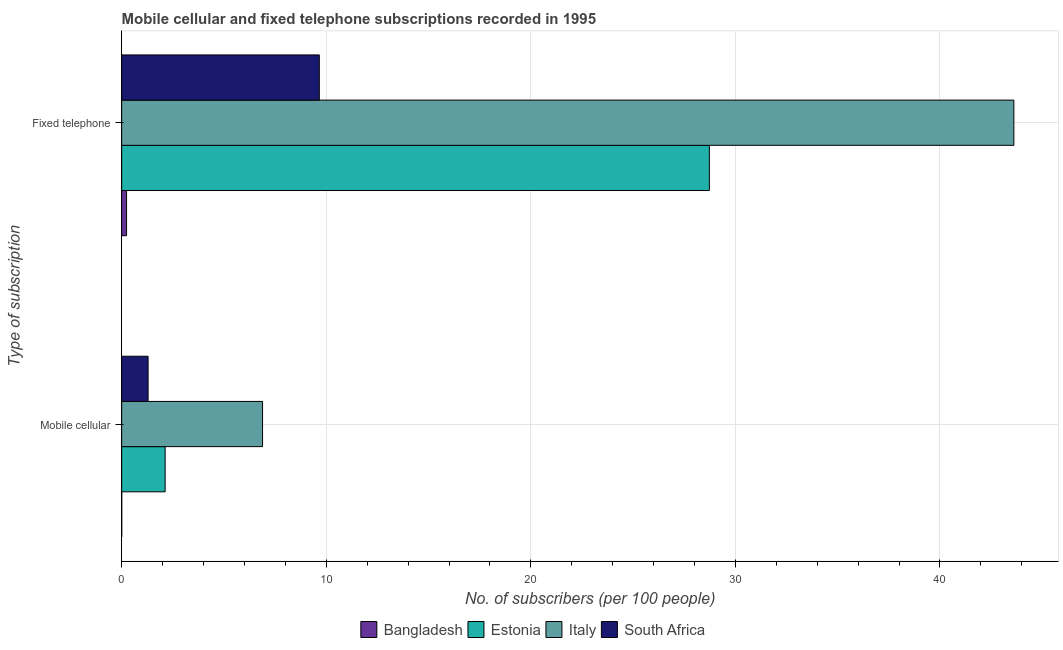How many different coloured bars are there?
Make the answer very short. 4. How many groups of bars are there?
Provide a succinct answer. 2. Are the number of bars on each tick of the Y-axis equal?
Your answer should be very brief. Yes. What is the label of the 1st group of bars from the top?
Offer a terse response. Fixed telephone. What is the number of fixed telephone subscribers in Italy?
Provide a short and direct response. 43.61. Across all countries, what is the maximum number of mobile cellular subscribers?
Your answer should be very brief. 6.89. Across all countries, what is the minimum number of fixed telephone subscribers?
Your answer should be compact. 0.24. In which country was the number of mobile cellular subscribers minimum?
Make the answer very short. Bangladesh. What is the total number of fixed telephone subscribers in the graph?
Ensure brevity in your answer.  82.24. What is the difference between the number of mobile cellular subscribers in Bangladesh and that in Italy?
Your answer should be compact. -6.88. What is the difference between the number of fixed telephone subscribers in Italy and the number of mobile cellular subscribers in Bangladesh?
Offer a very short reply. 43.61. What is the average number of fixed telephone subscribers per country?
Your answer should be very brief. 20.56. What is the difference between the number of fixed telephone subscribers and number of mobile cellular subscribers in Italy?
Your response must be concise. 36.73. In how many countries, is the number of mobile cellular subscribers greater than 28 ?
Your response must be concise. 0. What is the ratio of the number of mobile cellular subscribers in Bangladesh to that in Italy?
Provide a short and direct response. 0. Is the number of fixed telephone subscribers in South Africa less than that in Bangladesh?
Give a very brief answer. No. In how many countries, is the number of fixed telephone subscribers greater than the average number of fixed telephone subscribers taken over all countries?
Your answer should be compact. 2. What does the 3rd bar from the top in Mobile cellular represents?
Your answer should be very brief. Estonia. What does the 4th bar from the bottom in Mobile cellular represents?
Offer a very short reply. South Africa. How many bars are there?
Offer a terse response. 8. Are all the bars in the graph horizontal?
Make the answer very short. Yes. How many countries are there in the graph?
Provide a short and direct response. 4. Are the values on the major ticks of X-axis written in scientific E-notation?
Keep it short and to the point. No. Does the graph contain any zero values?
Your answer should be compact. No. Where does the legend appear in the graph?
Your answer should be very brief. Bottom center. How many legend labels are there?
Keep it short and to the point. 4. What is the title of the graph?
Your answer should be compact. Mobile cellular and fixed telephone subscriptions recorded in 1995. Does "Estonia" appear as one of the legend labels in the graph?
Your answer should be compact. Yes. What is the label or title of the X-axis?
Your answer should be very brief. No. of subscribers (per 100 people). What is the label or title of the Y-axis?
Your response must be concise. Type of subscription. What is the No. of subscribers (per 100 people) in Bangladesh in Mobile cellular?
Your answer should be compact. 0. What is the No. of subscribers (per 100 people) in Estonia in Mobile cellular?
Give a very brief answer. 2.12. What is the No. of subscribers (per 100 people) in Italy in Mobile cellular?
Your answer should be very brief. 6.89. What is the No. of subscribers (per 100 people) of South Africa in Mobile cellular?
Offer a terse response. 1.29. What is the No. of subscribers (per 100 people) in Bangladesh in Fixed telephone?
Your answer should be compact. 0.24. What is the No. of subscribers (per 100 people) in Estonia in Fixed telephone?
Make the answer very short. 28.73. What is the No. of subscribers (per 100 people) in Italy in Fixed telephone?
Give a very brief answer. 43.61. What is the No. of subscribers (per 100 people) in South Africa in Fixed telephone?
Make the answer very short. 9.66. Across all Type of subscription, what is the maximum No. of subscribers (per 100 people) of Bangladesh?
Your response must be concise. 0.24. Across all Type of subscription, what is the maximum No. of subscribers (per 100 people) in Estonia?
Your answer should be compact. 28.73. Across all Type of subscription, what is the maximum No. of subscribers (per 100 people) of Italy?
Make the answer very short. 43.61. Across all Type of subscription, what is the maximum No. of subscribers (per 100 people) of South Africa?
Your answer should be compact. 9.66. Across all Type of subscription, what is the minimum No. of subscribers (per 100 people) in Bangladesh?
Your response must be concise. 0. Across all Type of subscription, what is the minimum No. of subscribers (per 100 people) of Estonia?
Your answer should be very brief. 2.12. Across all Type of subscription, what is the minimum No. of subscribers (per 100 people) of Italy?
Your answer should be very brief. 6.89. Across all Type of subscription, what is the minimum No. of subscribers (per 100 people) in South Africa?
Provide a short and direct response. 1.29. What is the total No. of subscribers (per 100 people) in Bangladesh in the graph?
Offer a terse response. 0.24. What is the total No. of subscribers (per 100 people) of Estonia in the graph?
Your answer should be very brief. 30.85. What is the total No. of subscribers (per 100 people) of Italy in the graph?
Keep it short and to the point. 50.5. What is the total No. of subscribers (per 100 people) of South Africa in the graph?
Provide a succinct answer. 10.95. What is the difference between the No. of subscribers (per 100 people) of Bangladesh in Mobile cellular and that in Fixed telephone?
Offer a terse response. -0.24. What is the difference between the No. of subscribers (per 100 people) of Estonia in Mobile cellular and that in Fixed telephone?
Make the answer very short. -26.6. What is the difference between the No. of subscribers (per 100 people) in Italy in Mobile cellular and that in Fixed telephone?
Provide a succinct answer. -36.73. What is the difference between the No. of subscribers (per 100 people) of South Africa in Mobile cellular and that in Fixed telephone?
Your answer should be compact. -8.37. What is the difference between the No. of subscribers (per 100 people) of Bangladesh in Mobile cellular and the No. of subscribers (per 100 people) of Estonia in Fixed telephone?
Give a very brief answer. -28.72. What is the difference between the No. of subscribers (per 100 people) of Bangladesh in Mobile cellular and the No. of subscribers (per 100 people) of Italy in Fixed telephone?
Ensure brevity in your answer.  -43.61. What is the difference between the No. of subscribers (per 100 people) of Bangladesh in Mobile cellular and the No. of subscribers (per 100 people) of South Africa in Fixed telephone?
Give a very brief answer. -9.66. What is the difference between the No. of subscribers (per 100 people) of Estonia in Mobile cellular and the No. of subscribers (per 100 people) of Italy in Fixed telephone?
Offer a terse response. -41.49. What is the difference between the No. of subscribers (per 100 people) of Estonia in Mobile cellular and the No. of subscribers (per 100 people) of South Africa in Fixed telephone?
Provide a short and direct response. -7.54. What is the difference between the No. of subscribers (per 100 people) in Italy in Mobile cellular and the No. of subscribers (per 100 people) in South Africa in Fixed telephone?
Your answer should be very brief. -2.77. What is the average No. of subscribers (per 100 people) of Bangladesh per Type of subscription?
Your response must be concise. 0.12. What is the average No. of subscribers (per 100 people) in Estonia per Type of subscription?
Your response must be concise. 15.43. What is the average No. of subscribers (per 100 people) in Italy per Type of subscription?
Make the answer very short. 25.25. What is the average No. of subscribers (per 100 people) of South Africa per Type of subscription?
Keep it short and to the point. 5.48. What is the difference between the No. of subscribers (per 100 people) of Bangladesh and No. of subscribers (per 100 people) of Estonia in Mobile cellular?
Give a very brief answer. -2.12. What is the difference between the No. of subscribers (per 100 people) of Bangladesh and No. of subscribers (per 100 people) of Italy in Mobile cellular?
Offer a very short reply. -6.88. What is the difference between the No. of subscribers (per 100 people) of Bangladesh and No. of subscribers (per 100 people) of South Africa in Mobile cellular?
Provide a short and direct response. -1.29. What is the difference between the No. of subscribers (per 100 people) of Estonia and No. of subscribers (per 100 people) of Italy in Mobile cellular?
Your answer should be very brief. -4.76. What is the difference between the No. of subscribers (per 100 people) in Estonia and No. of subscribers (per 100 people) in South Africa in Mobile cellular?
Provide a short and direct response. 0.83. What is the difference between the No. of subscribers (per 100 people) in Italy and No. of subscribers (per 100 people) in South Africa in Mobile cellular?
Give a very brief answer. 5.59. What is the difference between the No. of subscribers (per 100 people) in Bangladesh and No. of subscribers (per 100 people) in Estonia in Fixed telephone?
Offer a terse response. -28.49. What is the difference between the No. of subscribers (per 100 people) of Bangladesh and No. of subscribers (per 100 people) of Italy in Fixed telephone?
Offer a terse response. -43.37. What is the difference between the No. of subscribers (per 100 people) of Bangladesh and No. of subscribers (per 100 people) of South Africa in Fixed telephone?
Ensure brevity in your answer.  -9.42. What is the difference between the No. of subscribers (per 100 people) in Estonia and No. of subscribers (per 100 people) in Italy in Fixed telephone?
Provide a short and direct response. -14.89. What is the difference between the No. of subscribers (per 100 people) of Estonia and No. of subscribers (per 100 people) of South Africa in Fixed telephone?
Offer a very short reply. 19.07. What is the difference between the No. of subscribers (per 100 people) of Italy and No. of subscribers (per 100 people) of South Africa in Fixed telephone?
Make the answer very short. 33.95. What is the ratio of the No. of subscribers (per 100 people) of Bangladesh in Mobile cellular to that in Fixed telephone?
Your response must be concise. 0.01. What is the ratio of the No. of subscribers (per 100 people) of Estonia in Mobile cellular to that in Fixed telephone?
Provide a succinct answer. 0.07. What is the ratio of the No. of subscribers (per 100 people) of Italy in Mobile cellular to that in Fixed telephone?
Your answer should be very brief. 0.16. What is the ratio of the No. of subscribers (per 100 people) in South Africa in Mobile cellular to that in Fixed telephone?
Provide a short and direct response. 0.13. What is the difference between the highest and the second highest No. of subscribers (per 100 people) of Bangladesh?
Give a very brief answer. 0.24. What is the difference between the highest and the second highest No. of subscribers (per 100 people) in Estonia?
Make the answer very short. 26.6. What is the difference between the highest and the second highest No. of subscribers (per 100 people) of Italy?
Offer a terse response. 36.73. What is the difference between the highest and the second highest No. of subscribers (per 100 people) of South Africa?
Keep it short and to the point. 8.37. What is the difference between the highest and the lowest No. of subscribers (per 100 people) of Bangladesh?
Offer a very short reply. 0.24. What is the difference between the highest and the lowest No. of subscribers (per 100 people) in Estonia?
Provide a succinct answer. 26.6. What is the difference between the highest and the lowest No. of subscribers (per 100 people) in Italy?
Your response must be concise. 36.73. What is the difference between the highest and the lowest No. of subscribers (per 100 people) in South Africa?
Offer a terse response. 8.37. 